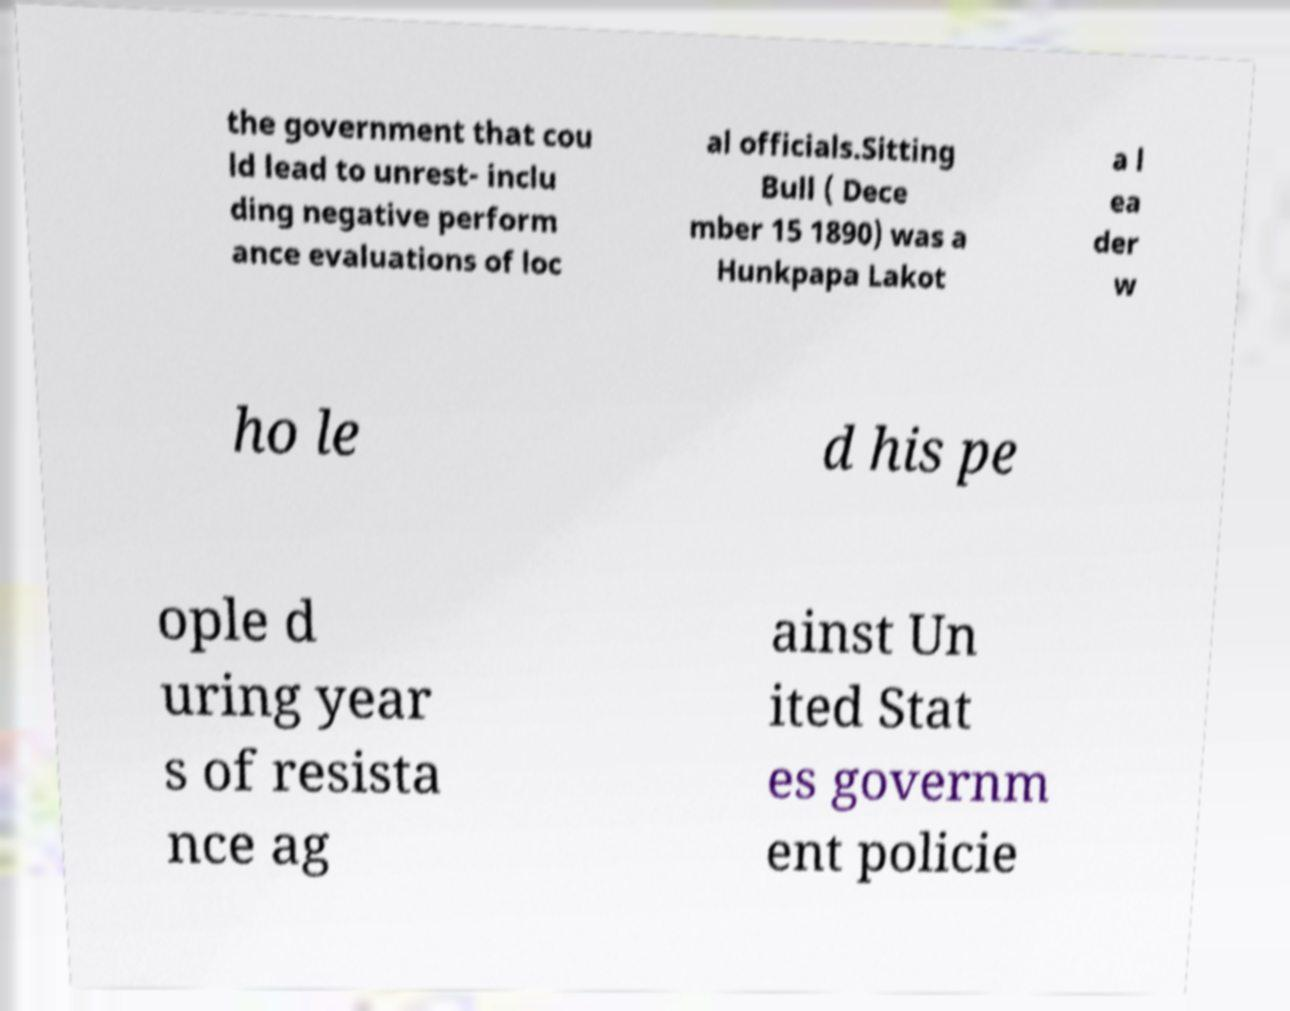Can you read and provide the text displayed in the image?This photo seems to have some interesting text. Can you extract and type it out for me? the government that cou ld lead to unrest- inclu ding negative perform ance evaluations of loc al officials.Sitting Bull ( Dece mber 15 1890) was a Hunkpapa Lakot a l ea der w ho le d his pe ople d uring year s of resista nce ag ainst Un ited Stat es governm ent policie 